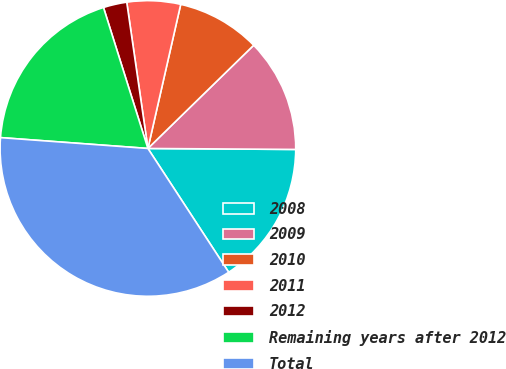Convert chart to OTSL. <chart><loc_0><loc_0><loc_500><loc_500><pie_chart><fcel>2008<fcel>2009<fcel>2010<fcel>2011<fcel>2012<fcel>Remaining years after 2012<fcel>Total<nl><fcel>15.69%<fcel>12.41%<fcel>9.13%<fcel>5.85%<fcel>2.57%<fcel>18.97%<fcel>35.37%<nl></chart> 